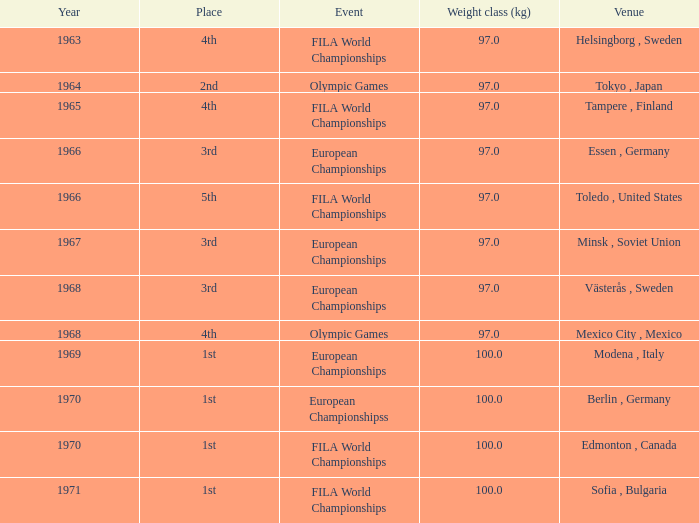Could you help me parse every detail presented in this table? {'header': ['Year', 'Place', 'Event', 'Weight class (kg)', 'Venue'], 'rows': [['1963', '4th', 'FILA World Championships', '97.0', 'Helsingborg , Sweden'], ['1964', '2nd', 'Olympic Games', '97.0', 'Tokyo , Japan'], ['1965', '4th', 'FILA World Championships', '97.0', 'Tampere , Finland'], ['1966', '3rd', 'European Championships', '97.0', 'Essen , Germany'], ['1966', '5th', 'FILA World Championships', '97.0', 'Toledo , United States'], ['1967', '3rd', 'European Championships', '97.0', 'Minsk , Soviet Union'], ['1968', '3rd', 'European Championships', '97.0', 'Västerås , Sweden'], ['1968', '4th', 'Olympic Games', '97.0', 'Mexico City , Mexico'], ['1969', '1st', 'European Championships', '100.0', 'Modena , Italy'], ['1970', '1st', 'European Championshipss', '100.0', 'Berlin , Germany'], ['1970', '1st', 'FILA World Championships', '100.0', 'Edmonton , Canada'], ['1971', '1st', 'FILA World Championships', '100.0', 'Sofia , Bulgaria']]} What is the lowest year that has edmonton, canada as the venue with a weight class (kg) greater than 100? None. 